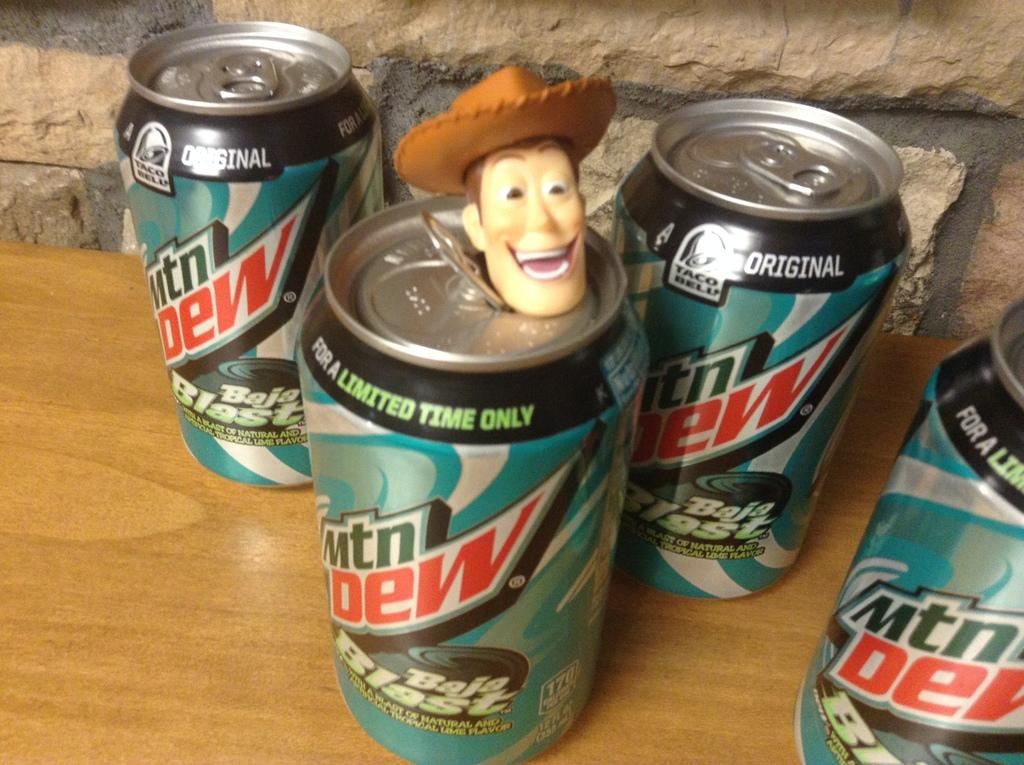<image>
Offer a succinct explanation of the picture presented. 4 botles of mtn dew brand new sit on the counter 